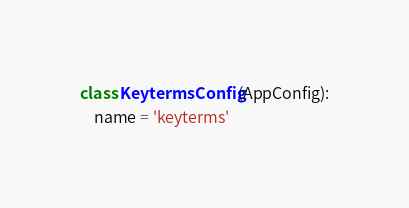<code> <loc_0><loc_0><loc_500><loc_500><_Python_>
class KeytermsConfig(AppConfig):
    name = 'keyterms'
</code> 